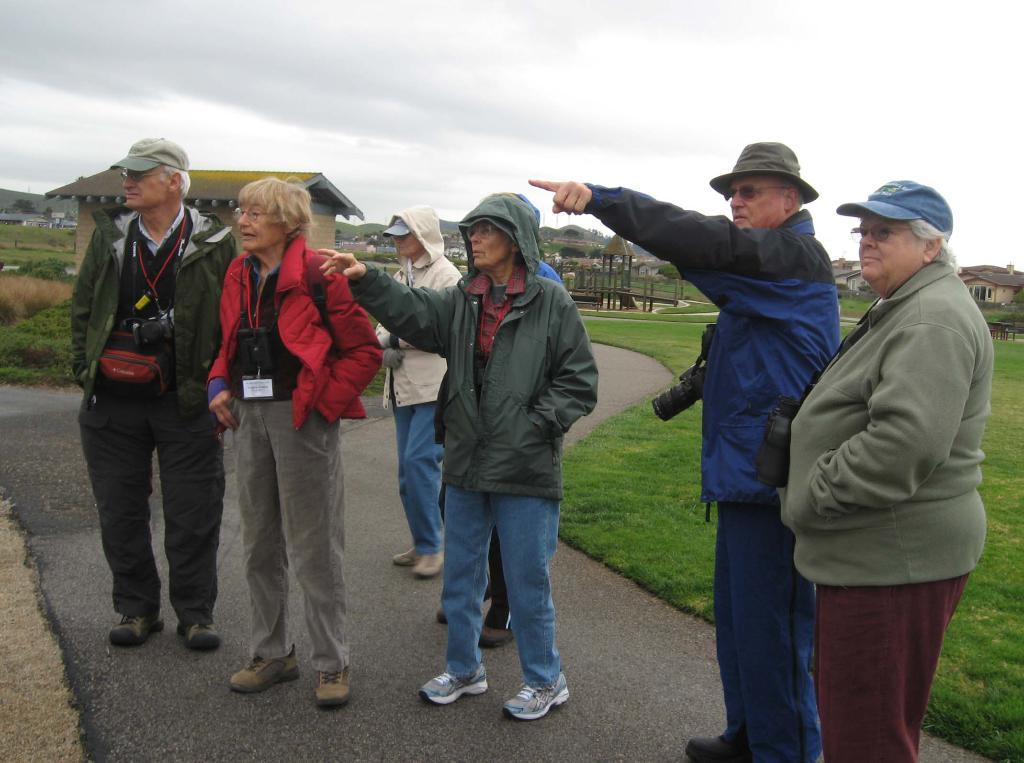What are the people in the image doing? The people in the image are standing on a road. What can be seen in the background of the image? There is grassland and houses in the background of the image. What is visible in the sky in the image? The sky is visible in the background of the image. What thoughts are going through the people's minds in the image? There is no way to determine the thoughts of the people in the image based on the visual information provided. 